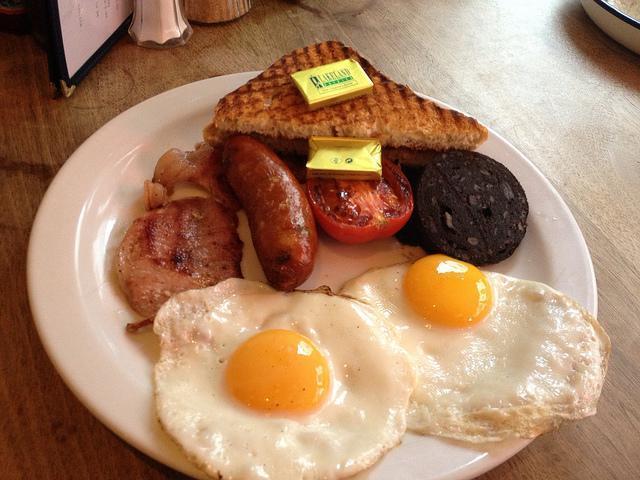How many foil butter is on the plate?
Give a very brief answer. 2. How many eggs are on this plate?
Give a very brief answer. 2. How many doughnut holes can you see in this picture?
Give a very brief answer. 0. How many sandwiches are there?
Give a very brief answer. 1. 